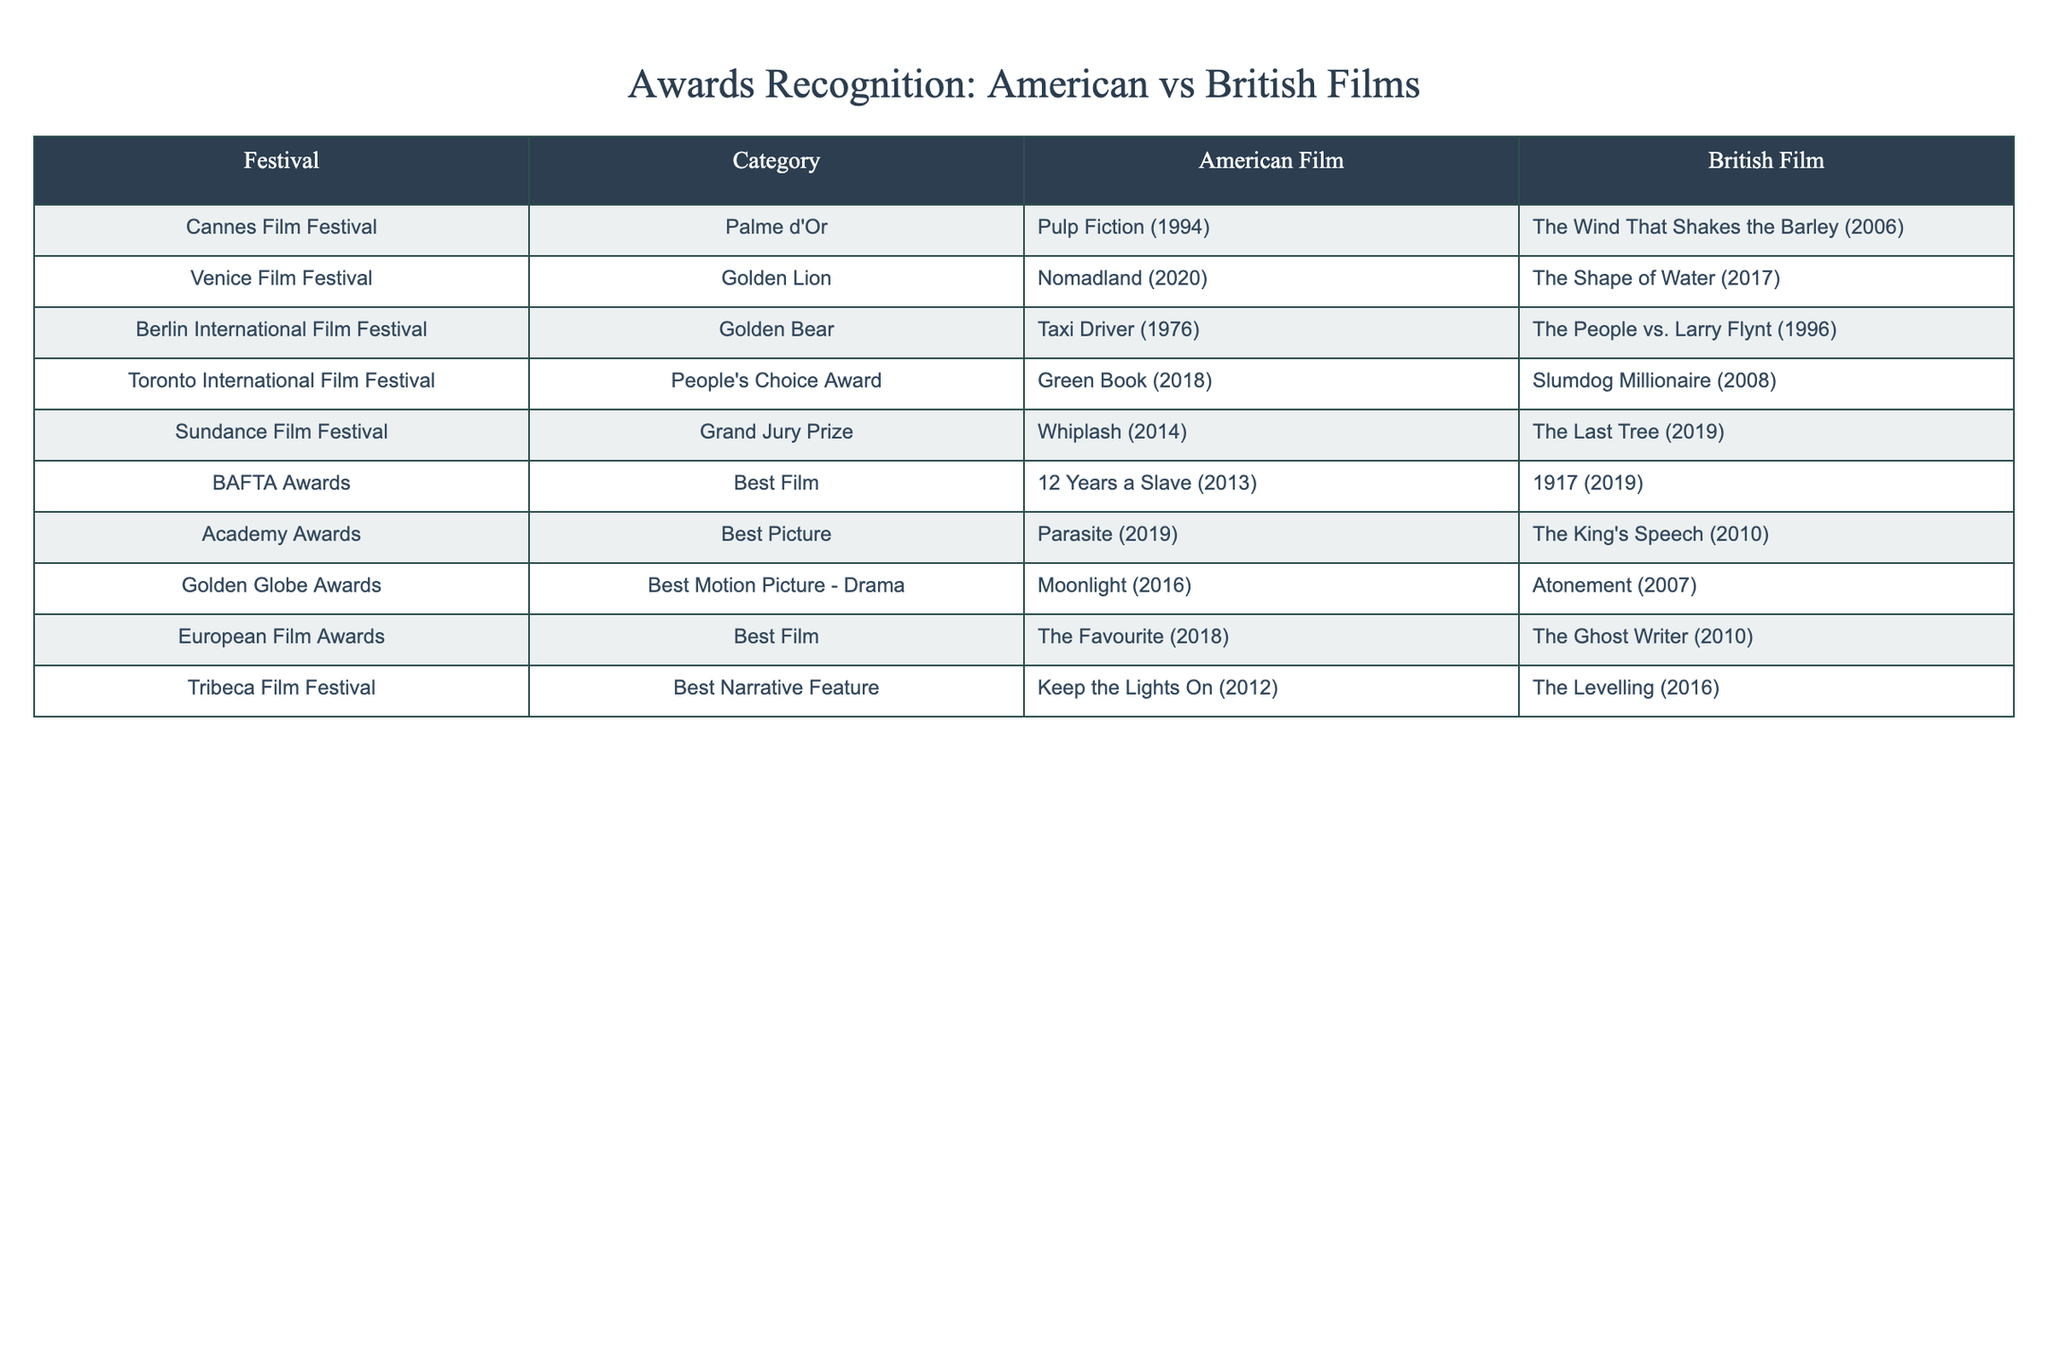What film won the Palme d'Or at the Cannes Film Festival for America? The table indicates that "Pulp Fiction" (1994) is the American film that won the Palme d'Or at the Cannes Film Festival.
Answer: Pulp Fiction (1994) Which British film won the Golden Lion at the Venice Film Festival? According to the table, "The Shape of Water" (2017) is the British film that won the Golden Lion at the Venice Film Festival.
Answer: The Shape of Water (2017) How many awards did American films win at the Berlin International Film Festival? The table shows that there are two entries for the Berlin International Film Festival, and both are American films, thus the number of awards won is 1.
Answer: 1 Did any British film win the Best Film category at the BAFTA Awards? Yes, according to the table, "1917" (2019) won the Best Film category at the BAFTA Awards for British films, making the answer True.
Answer: True Which festival recognized a British film with the People's Choice Award? From the table, "Slumdog Millionaire" (2008) is identified as the British film that received the People's Choice Award at the Toronto International Film Festival.
Answer: Slumdog Millionaire (2008) How many awards were awarded to British films in total at the listed festivals? The data shows one British film under each listed festival. There are eight festivals, so the total number of awards awarded to British films is 8.
Answer: 8 Was "Moonlight" recognized at the Golden Globe Awards for a film directed by an American filmmaker? The table indicates that "Moonlight" (2016) is the American film that won the Best Motion Picture - Drama category at the Golden Globe Awards, suggesting that the answer is True.
Answer: True Which film won the Grand Jury Prize at the Sundance Film Festival, and what is its release year? The table states that "Whiplash" (2014) won the Grand Jury Prize at the Sundance Film Festival, providing the film title and the release year together.
Answer: Whiplash (2014) Did any American film receive multiple awards at the same festival? Looking through the table, each festival has one film recognized for each country, and there are no entries indicating that an American film received multiple awards at the same festival, hence the answer is False.
Answer: False 